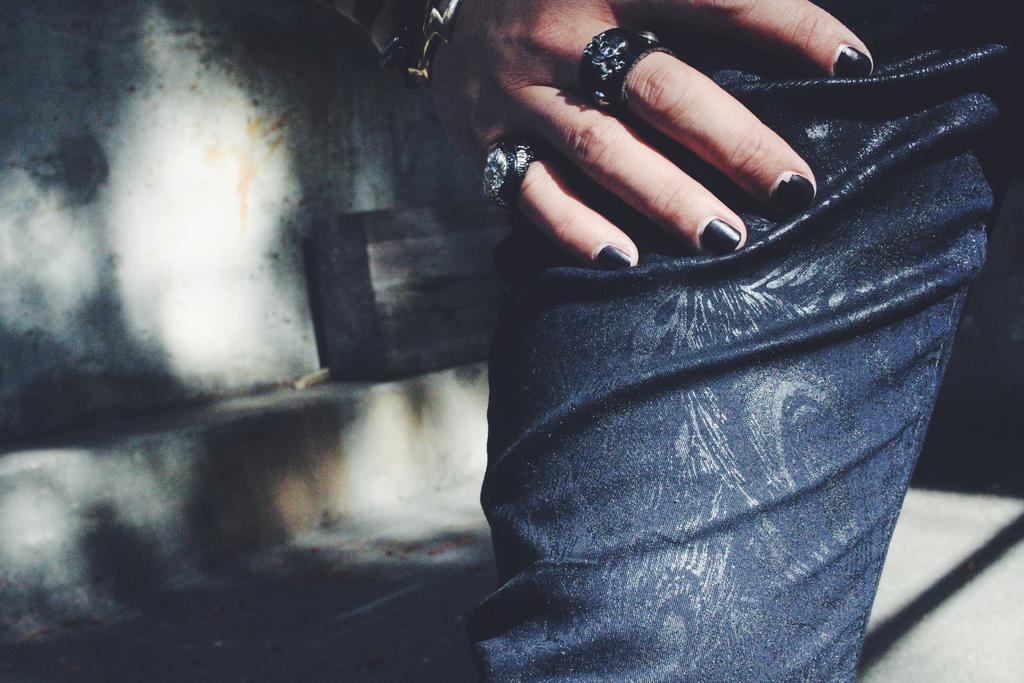Can you describe this image briefly? In this image we can see the leg and the hand of a person. We can also see some rings to his fingers. On the backside we can see a container which is placed beside a wall. 